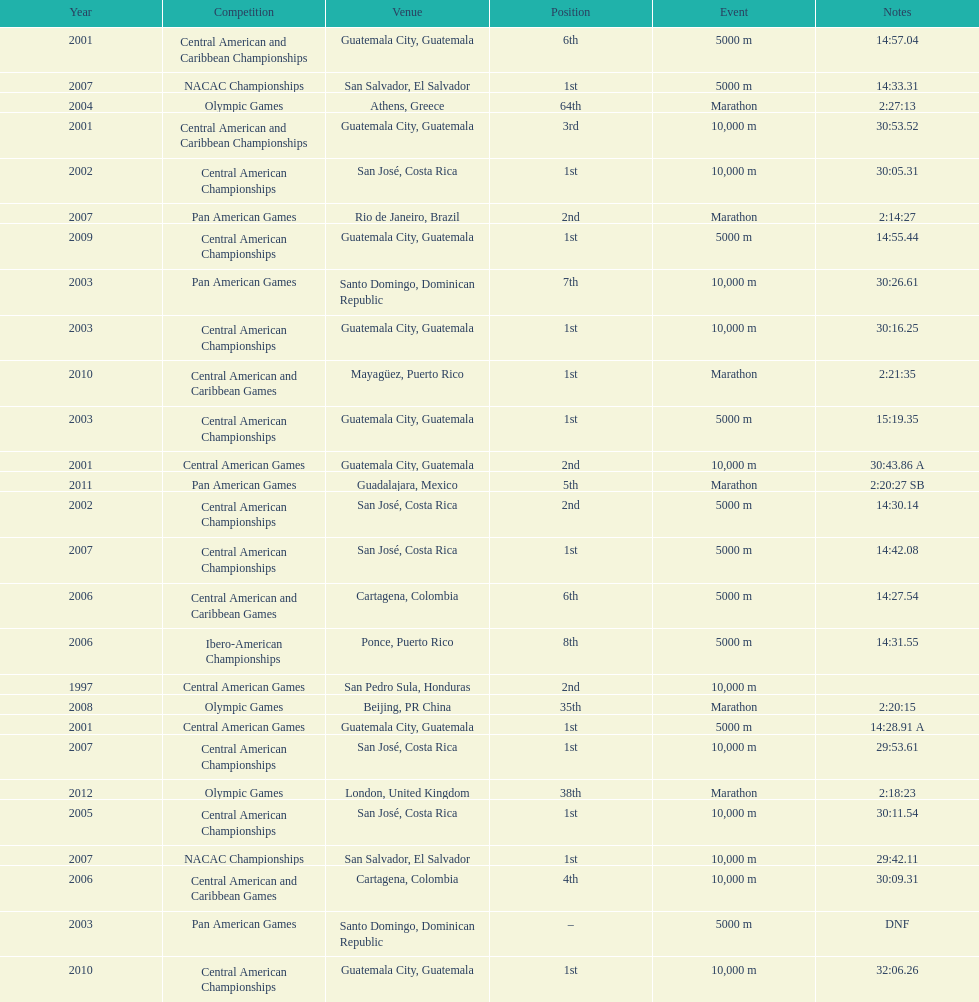The central american championships and what other competition occurred in 2010? Central American and Caribbean Games. 